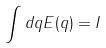Convert formula to latex. <formula><loc_0><loc_0><loc_500><loc_500>\int d q E ( q ) = I</formula> 